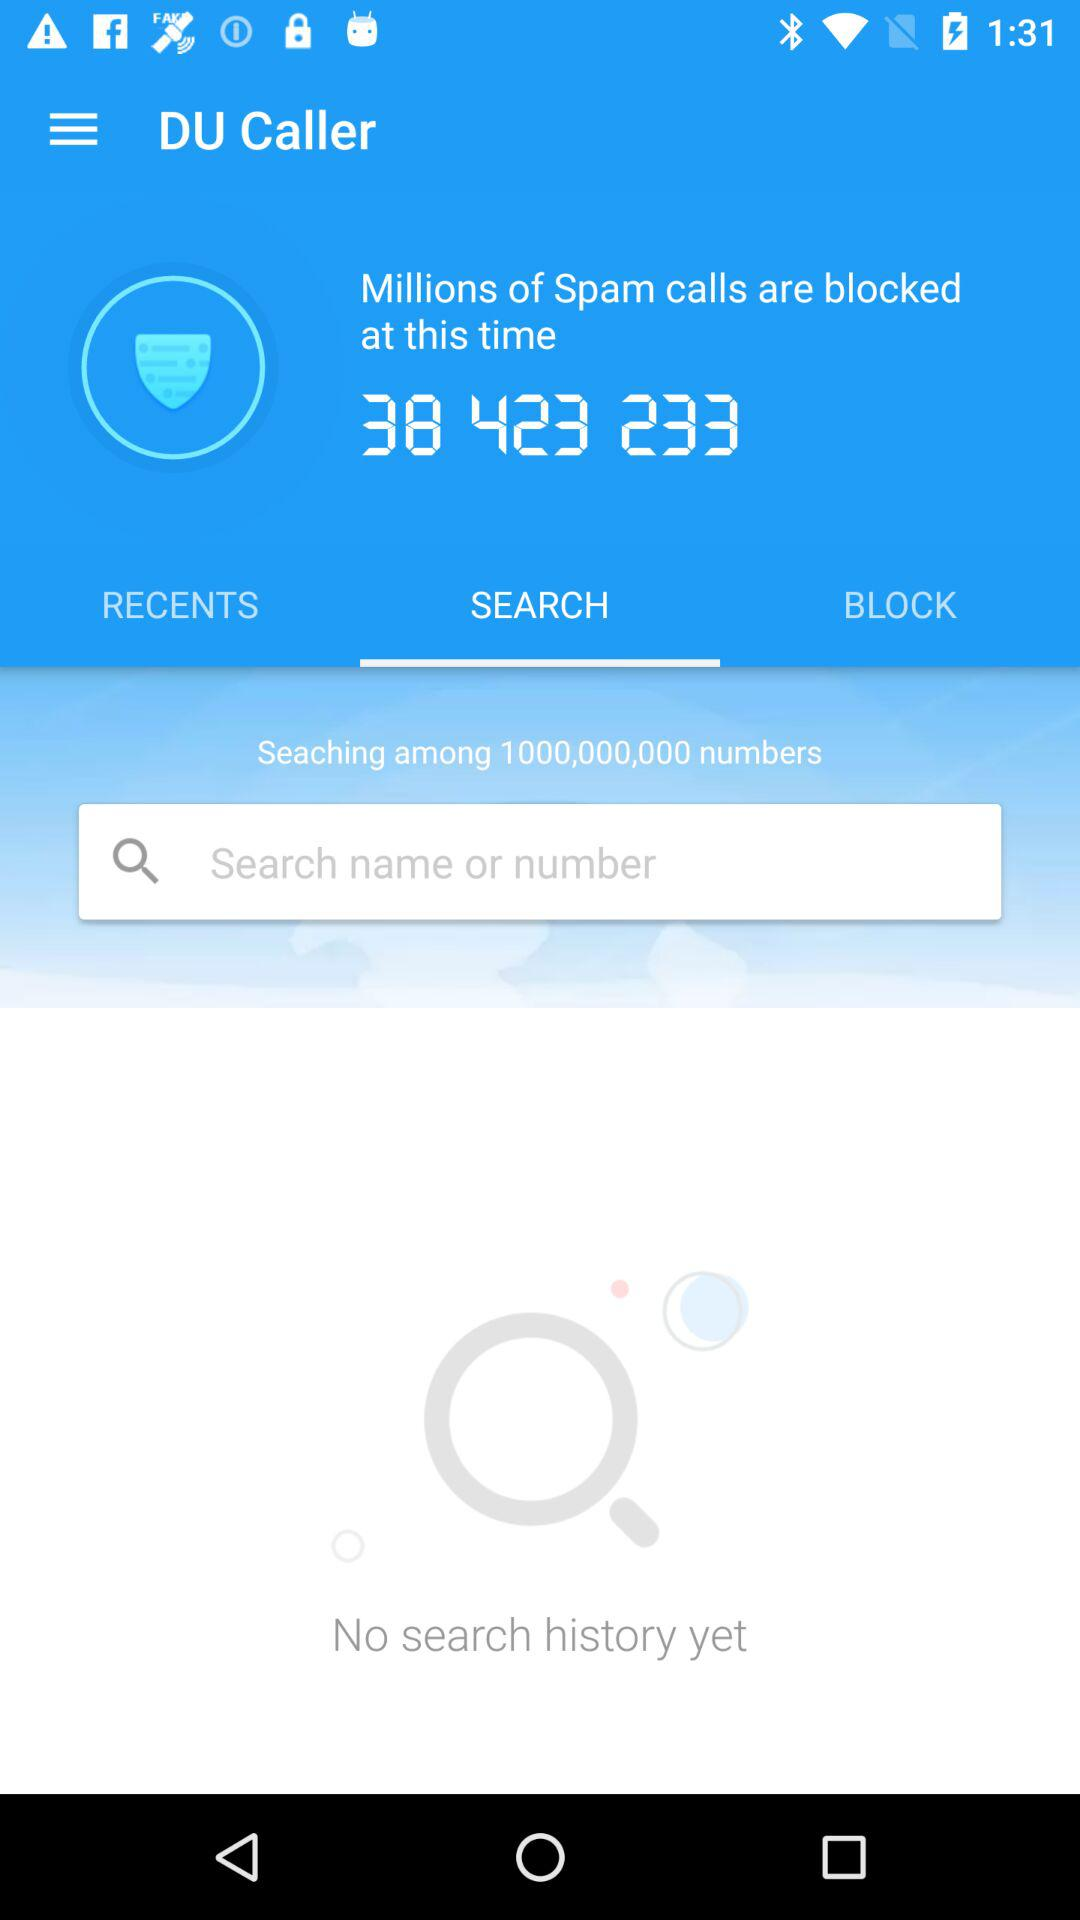What is the application name? The application name is "DU Caller". 